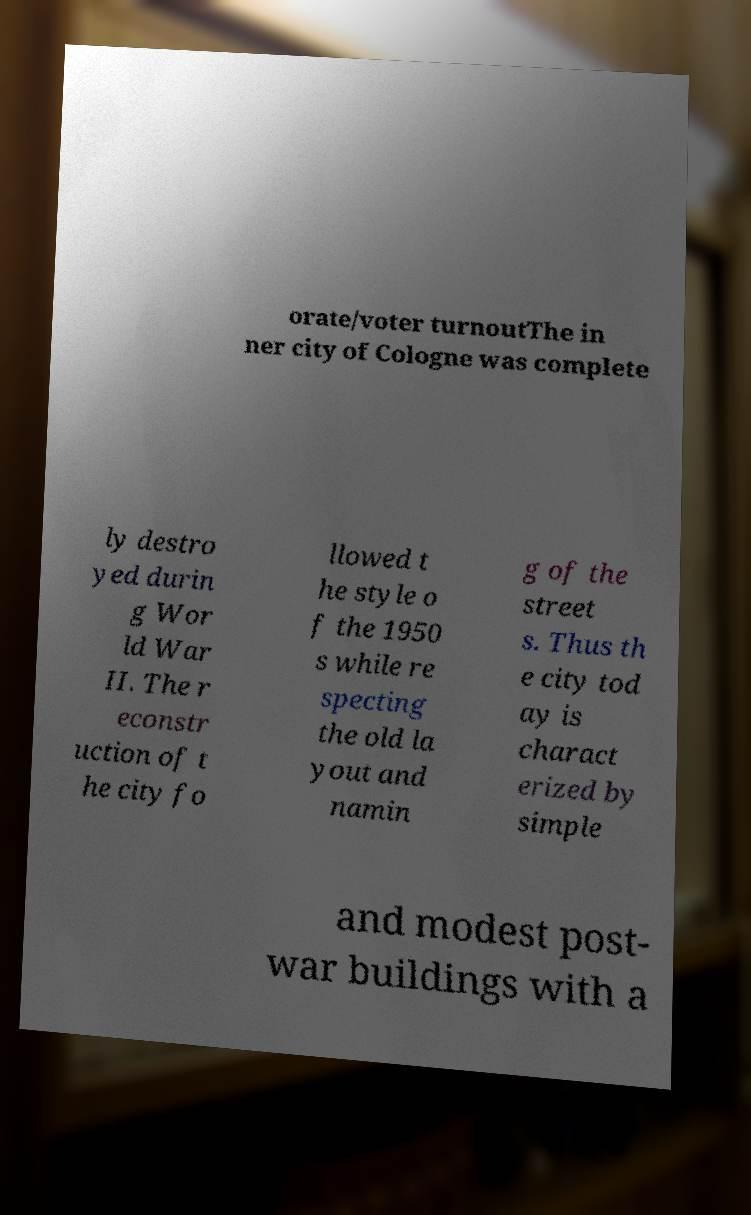Please identify and transcribe the text found in this image. orate/voter turnoutThe in ner city of Cologne was complete ly destro yed durin g Wor ld War II. The r econstr uction of t he city fo llowed t he style o f the 1950 s while re specting the old la yout and namin g of the street s. Thus th e city tod ay is charact erized by simple and modest post- war buildings with a 